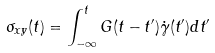Convert formula to latex. <formula><loc_0><loc_0><loc_500><loc_500>\sigma _ { x y } ( t ) = \int _ { - \infty } ^ { t } G ( t - t ^ { \prime } ) \dot { \gamma } ( t ^ { \prime } ) d t ^ { \prime }</formula> 